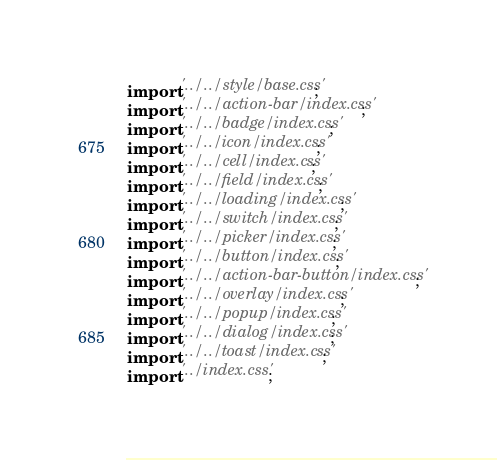<code> <loc_0><loc_0><loc_500><loc_500><_JavaScript_>import '../../style/base.css';
import '../../action-bar/index.css';
import '../../badge/index.css';
import '../../icon/index.css';
import '../../cell/index.css';
import '../../field/index.css';
import '../../loading/index.css';
import '../../switch/index.css';
import '../../picker/index.css';
import '../../button/index.css';
import '../../action-bar-button/index.css';
import '../../overlay/index.css';
import '../../popup/index.css';
import '../../dialog/index.css';
import '../../toast/index.css';
import '../index.css';</code> 